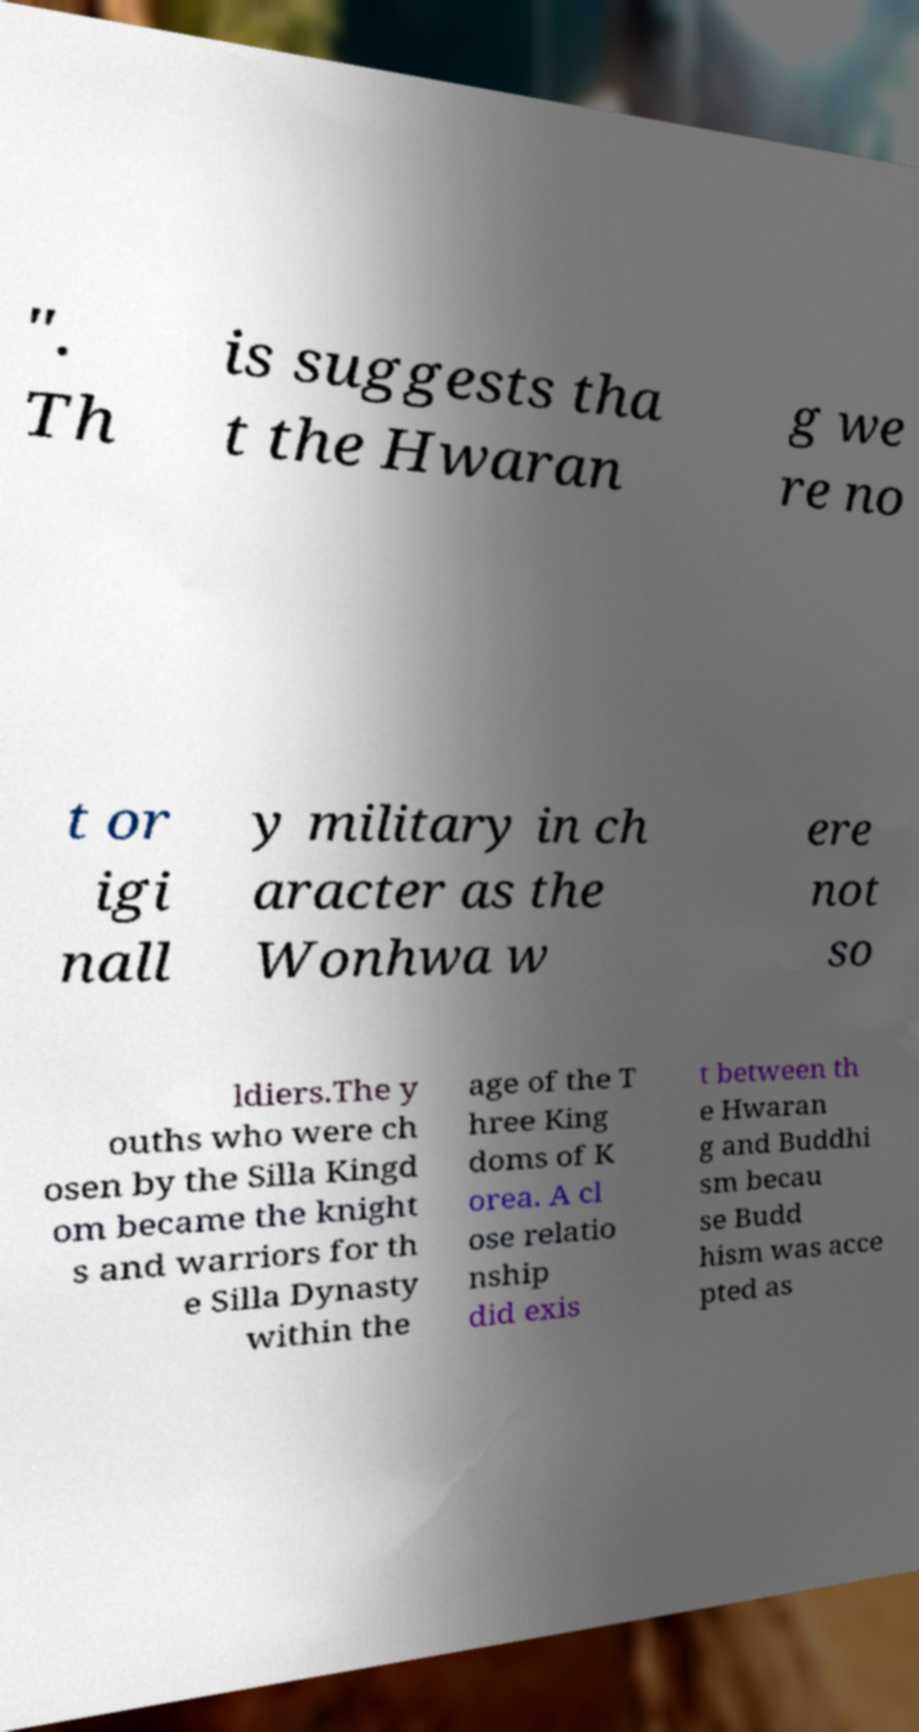Can you accurately transcribe the text from the provided image for me? ". Th is suggests tha t the Hwaran g we re no t or igi nall y military in ch aracter as the Wonhwa w ere not so ldiers.The y ouths who were ch osen by the Silla Kingd om became the knight s and warriors for th e Silla Dynasty within the age of the T hree King doms of K orea. A cl ose relatio nship did exis t between th e Hwaran g and Buddhi sm becau se Budd hism was acce pted as 